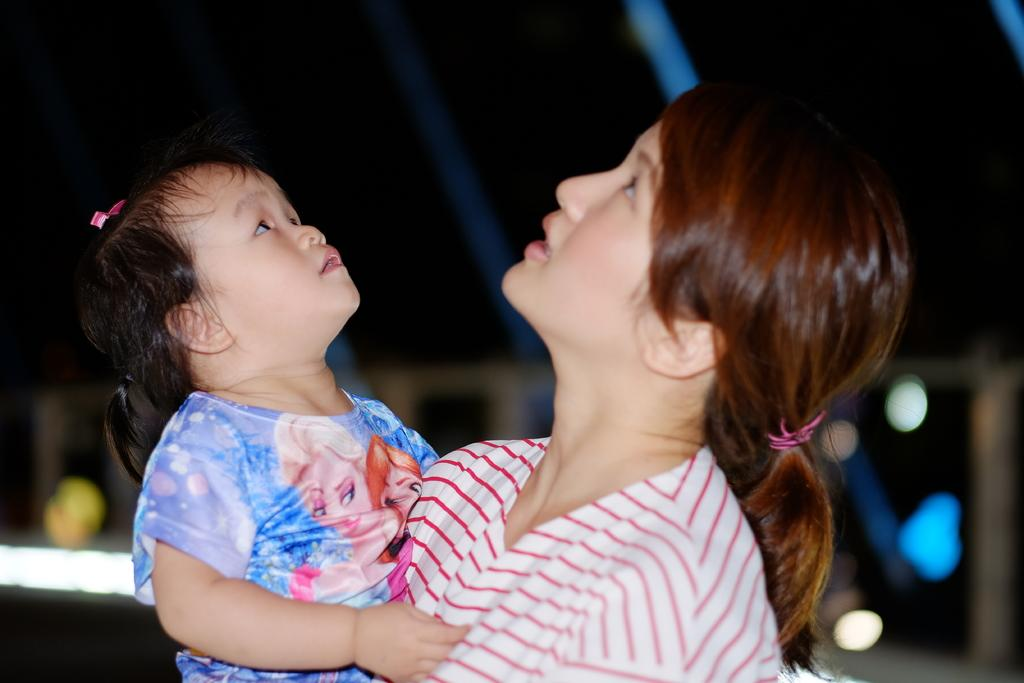Who is the main subject in the image? There is a woman in the image. What is the woman wearing? The woman is wearing a dress. What is the woman holding in the image? The woman is holding a baby. What can be seen in the background of the image? There are lights visible in the background of the image. Are there any grains visible in the image? There is no indication of grains in the image; it features a woman holding a baby with lights in the background. Can you see any cobwebs in the image? There is no mention of cobwebs in the image; it only shows a woman, a baby, and lights in the background. 